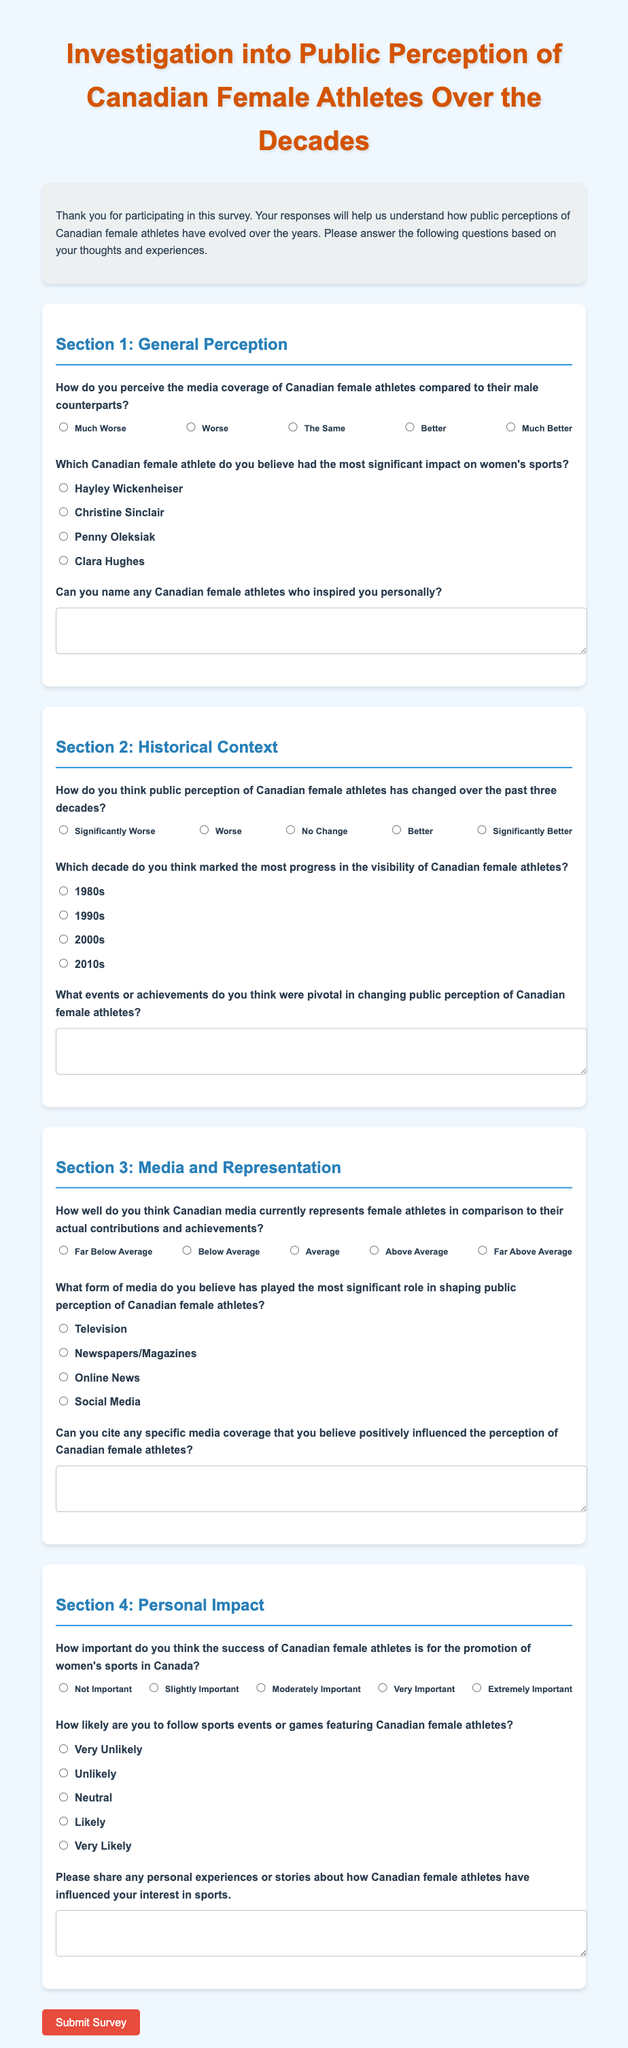What is the title of the survey? The title of the survey is prominently displayed at the top of the document.
Answer: Investigation into Public Perception of Canadian Female Athletes Over the Decades How many sections are in the survey? The survey is divided into distinct sections, each addressing a specific theme.
Answer: Four Who is the first athlete mentioned in the significant impact question? The question lists notable Canadian female athletes, with options provided for selection.
Answer: Hayley Wickenheiser What rating scale is used for assessing media coverage of female athletes? The scale provides five options ranging from negative to positive perceptions regarding media coverage.
Answer: 1 to 5 Which decade is considered the most progress in the visibility of female athletes? Respondents are asked to select a decade from the provided options based on their perception.
Answer: 1980s How likely are participants to follow sports events featuring Canadian female athletes? This question assesses the interest level of participants concerning events featuring female athletes.
Answer: Very Unlikely to Very Likely What type of media is considered most influential in shaping public perception? Respondents can choose from various media types that they believe impact perceptions significantly.
Answer: Social Media What text area is provided for sharing personal experiences? The document includes a specific area for participants to reflect and share insights related to Canadian female athletes.
Answer: Please share any personal experiences or stories about how Canadian female athletes have influenced your interest in sports 